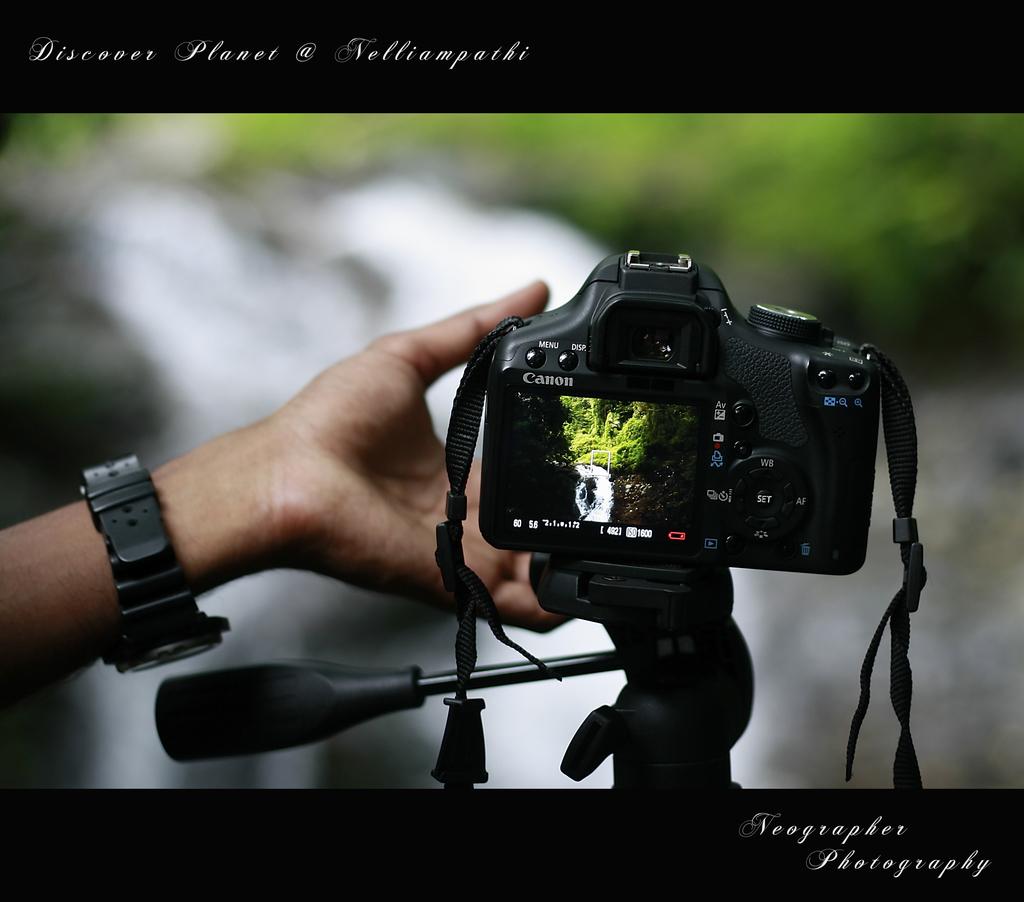What is the name of the photography company?
Your answer should be compact. Neographer photography. Who makes the camera?
Keep it short and to the point. Canon. 